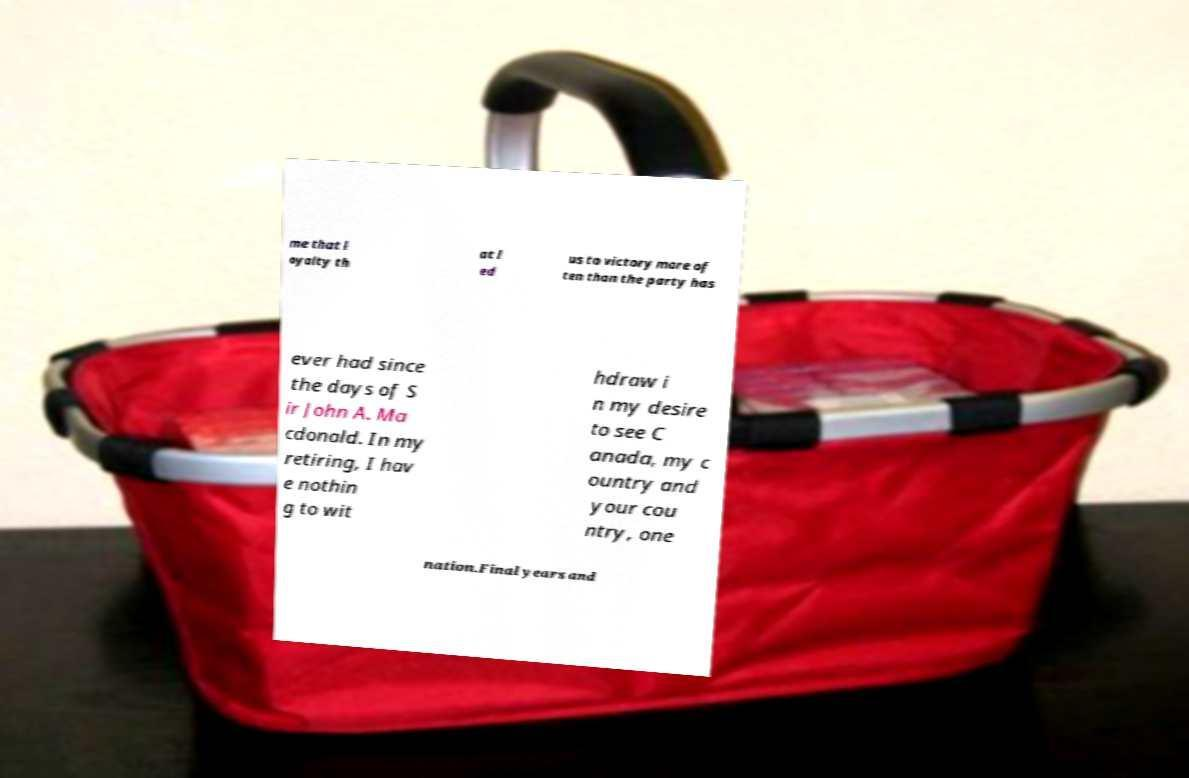There's text embedded in this image that I need extracted. Can you transcribe it verbatim? me that l oyalty th at l ed us to victory more of ten than the party has ever had since the days of S ir John A. Ma cdonald. In my retiring, I hav e nothin g to wit hdraw i n my desire to see C anada, my c ountry and your cou ntry, one nation.Final years and 